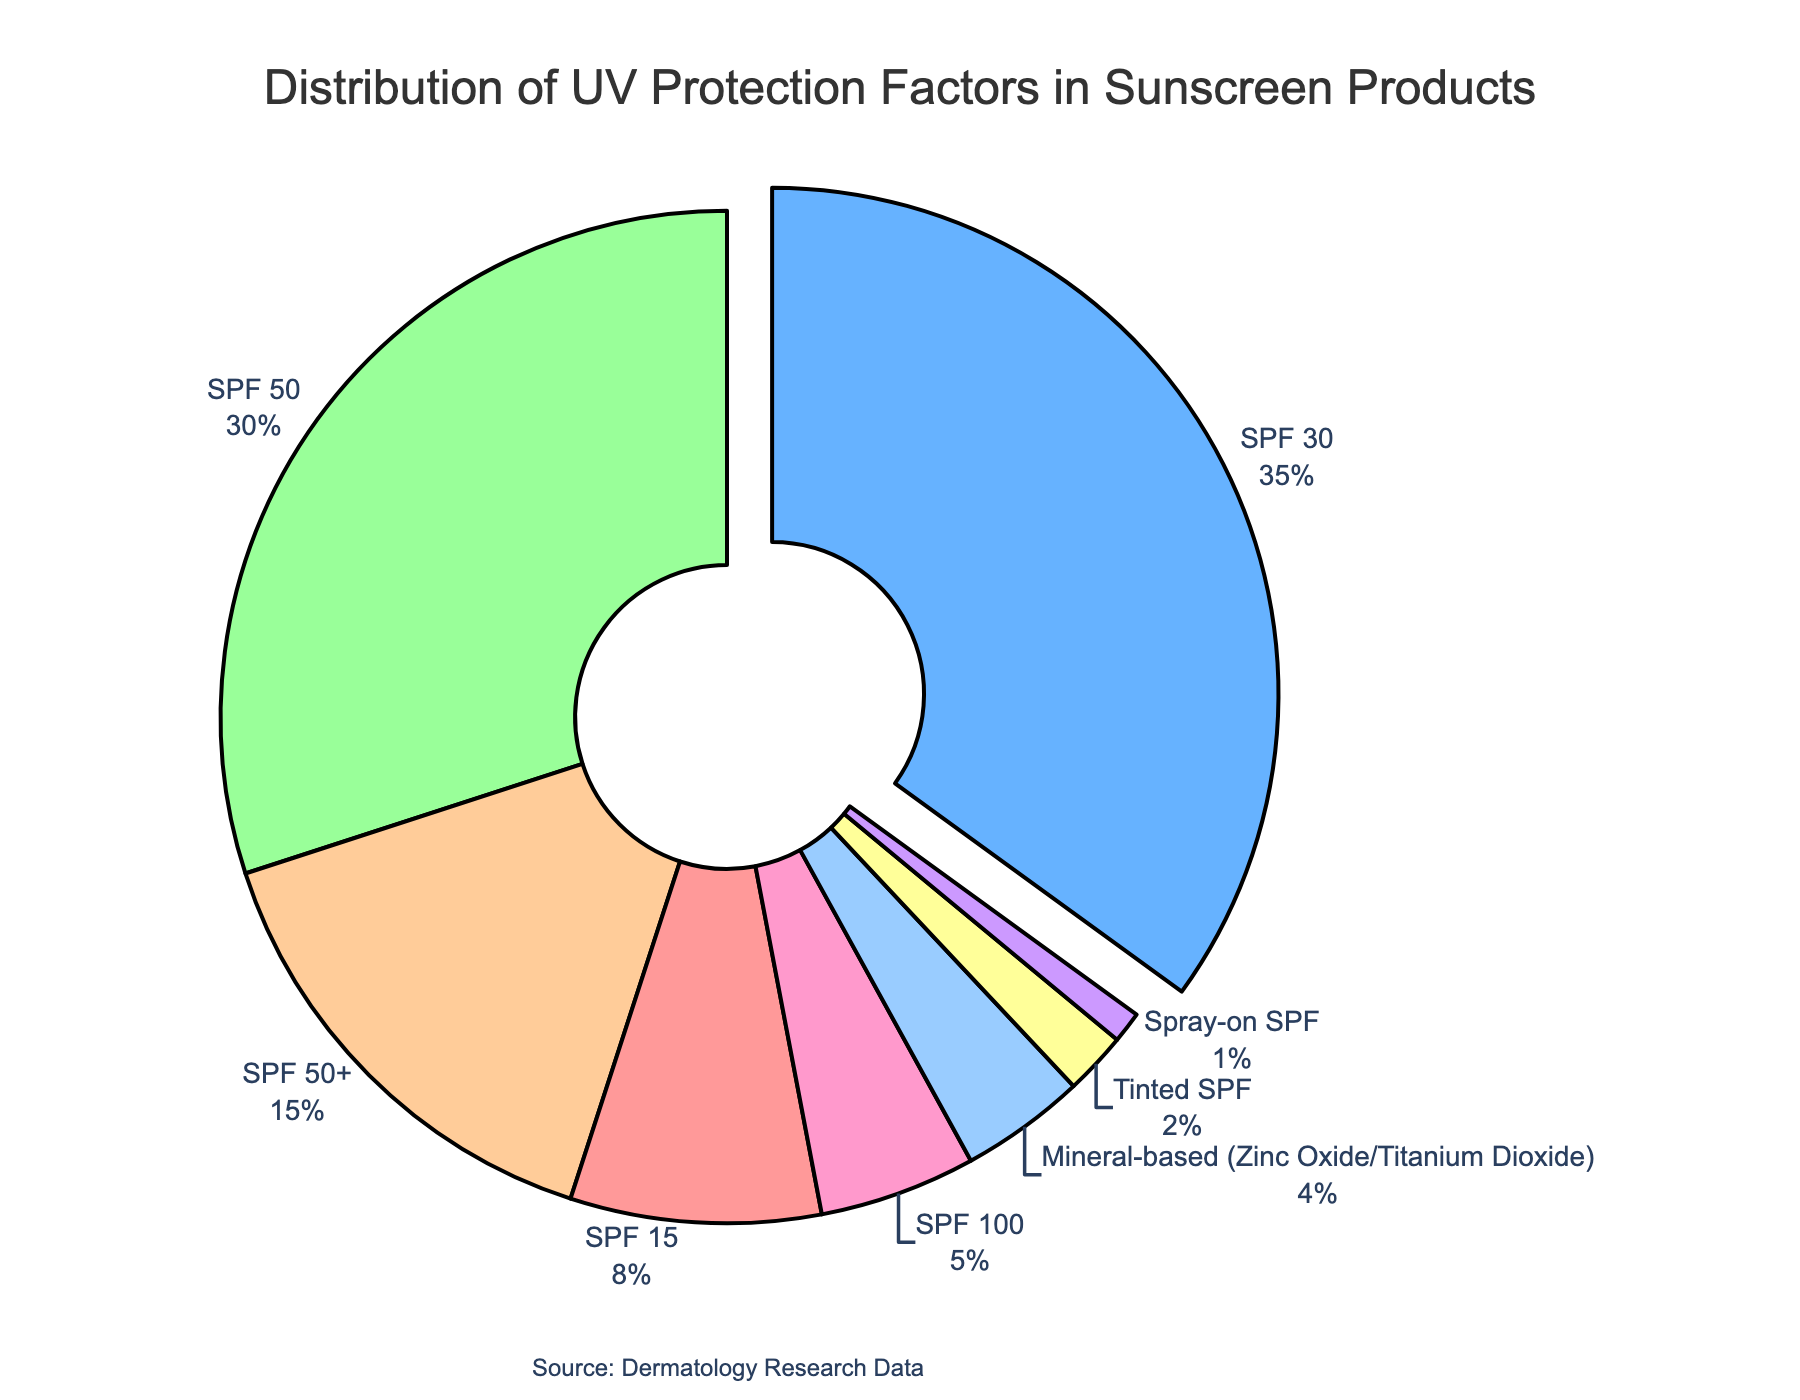What's the most common UV protection factor in sunscreen products? By looking at the figure, the largest portion of the pie chart is identified. The portion with SPF 30 has the largest area.
Answer: SPF 30 Which SPF rating corresponds to 15% of the sunscreen products? By referring to the figure, the section labeled "SPF 50+" is visually associated with 15%.
Answer: SPF 50+ How much more common is SPF 30 compared to SPF 15 in percentage points? According to the figure, SPF 30 is 35% and SPF 15 is 8%. The difference between them is 35% - 8% = 27%.
Answer: 27% What is the total percentage of sunscreen products with SPF ratings equal to or higher than 50? The figure shows three categories with SPF 50 or higher: SPF 50 at 30%, SPF 50+ at 15%, and SPF 100 at 5%. Summing these gives 30% + 15% + 5% = 50%.
Answer: 50% Which type of sunscreen product has the lowest percentage share? By examining the smallest slice in the pie chart, "Spray-on SPF" is identified as the smallest section, indicating it has the lowest percentage share at 1%.
Answer: Spray-on SPF What is the combined percentage of mineral-based and tinted SPF products? From the figure, mineral-based products are at 4%, and tinted SPF is at 2%. Their combined percentage is 4% + 2% = 6%.
Answer: 6% Which SPF rating is highlighted or pulled out in the pie chart? The visual characteristic of the most prominent slice being pulled out emphasizes that SPF 30 is highlighted.
Answer: SPF 30 Which sunscreen categories together make up less than 10% of the distribution? Referring to the small sections in the figure, Tinted SPF (2%), Spray-on SPF (1%), and Mineral-based SPF (4%) are added. Their sum is 2% + 1% + 4% = 7%, which is less than 10%.
Answer: Tinted SPF, Spray-on SPF, and Mineral-based SPF How much greater is the percentage of SPF 30 product than SPF 100? According to the pie chart, SPF 30 is at 35% and SPF 100 is at 5%. The difference is 35% - 5% = 30%.
Answer: 30% What cumulative percentage of the products are either SPF 30 or SPF 50? By summing the percentages shown in the figure for SPF 30 (35%) and SPF 50 (30%), we get 35% + 30% = 65%.
Answer: 65% 